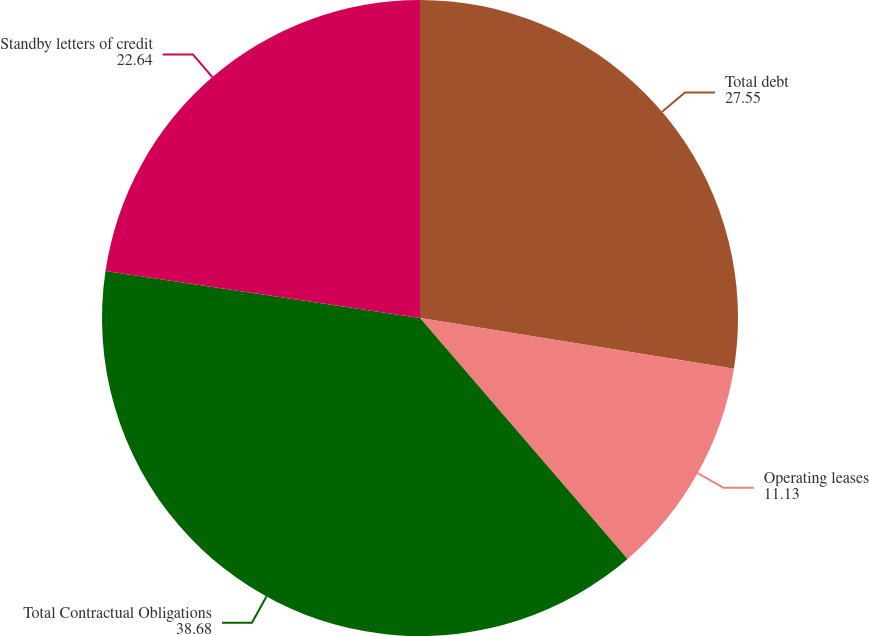Convert chart. <chart><loc_0><loc_0><loc_500><loc_500><pie_chart><fcel>Total debt<fcel>Operating leases<fcel>Total Contractual Obligations<fcel>Standby letters of credit<nl><fcel>27.55%<fcel>11.13%<fcel>38.68%<fcel>22.64%<nl></chart> 